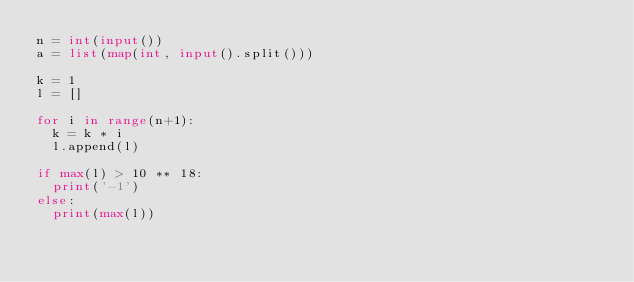<code> <loc_0><loc_0><loc_500><loc_500><_Python_>n = int(input())
a = list(map(int, input().split()))

k = 1
l = []

for i in range(n+1):
  k = k * i
  l.append(l)

if max(l) > 10 ** 18:
  print('-1')
else:
  print(max(l))

</code> 